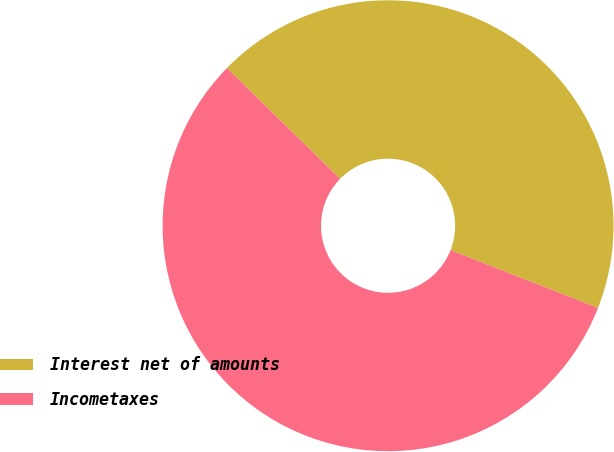<chart> <loc_0><loc_0><loc_500><loc_500><pie_chart><fcel>Interest net of amounts<fcel>Incometaxes<nl><fcel>43.61%<fcel>56.39%<nl></chart> 